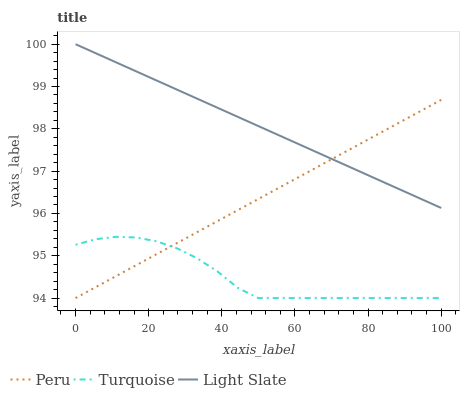Does Turquoise have the minimum area under the curve?
Answer yes or no. Yes. Does Light Slate have the maximum area under the curve?
Answer yes or no. Yes. Does Peru have the minimum area under the curve?
Answer yes or no. No. Does Peru have the maximum area under the curve?
Answer yes or no. No. Is Peru the smoothest?
Answer yes or no. Yes. Is Turquoise the roughest?
Answer yes or no. Yes. Is Turquoise the smoothest?
Answer yes or no. No. Is Peru the roughest?
Answer yes or no. No. Does Turquoise have the lowest value?
Answer yes or no. Yes. Does Light Slate have the highest value?
Answer yes or no. Yes. Does Peru have the highest value?
Answer yes or no. No. Is Turquoise less than Light Slate?
Answer yes or no. Yes. Is Light Slate greater than Turquoise?
Answer yes or no. Yes. Does Peru intersect Light Slate?
Answer yes or no. Yes. Is Peru less than Light Slate?
Answer yes or no. No. Is Peru greater than Light Slate?
Answer yes or no. No. Does Turquoise intersect Light Slate?
Answer yes or no. No. 